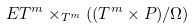Convert formula to latex. <formula><loc_0><loc_0><loc_500><loc_500>E T ^ { m } \times _ { T ^ { m } } ( ( T ^ { m } \times P ) / \Omega )</formula> 